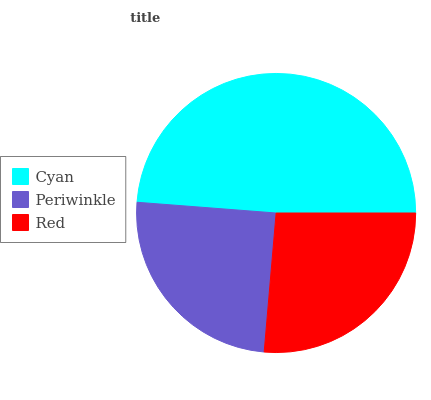Is Periwinkle the minimum?
Answer yes or no. Yes. Is Cyan the maximum?
Answer yes or no. Yes. Is Red the minimum?
Answer yes or no. No. Is Red the maximum?
Answer yes or no. No. Is Red greater than Periwinkle?
Answer yes or no. Yes. Is Periwinkle less than Red?
Answer yes or no. Yes. Is Periwinkle greater than Red?
Answer yes or no. No. Is Red less than Periwinkle?
Answer yes or no. No. Is Red the high median?
Answer yes or no. Yes. Is Red the low median?
Answer yes or no. Yes. Is Cyan the high median?
Answer yes or no. No. Is Cyan the low median?
Answer yes or no. No. 